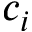Convert formula to latex. <formula><loc_0><loc_0><loc_500><loc_500>c _ { i }</formula> 